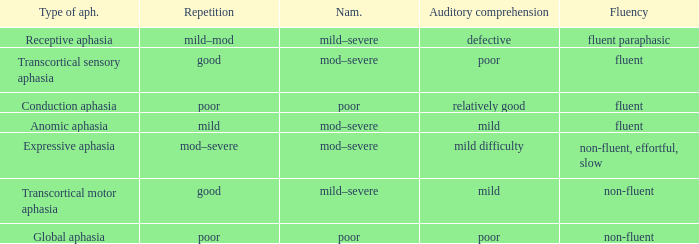Name the comprehension for non-fluent, effortful, slow Mild difficulty. 